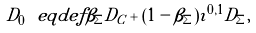<formula> <loc_0><loc_0><loc_500><loc_500>D _ { 0 } \ e q d e f \beta _ { \Sigma } D _ { C } + ( 1 - \beta _ { \Sigma } ) \imath ^ { 0 , 1 } D _ { \Sigma } ,</formula> 